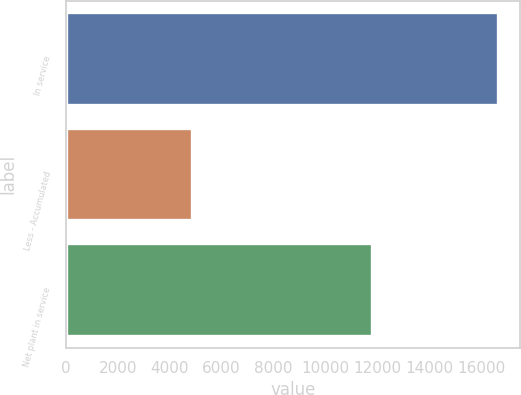Convert chart to OTSL. <chart><loc_0><loc_0><loc_500><loc_500><bar_chart><fcel>In service<fcel>Less - Accumulated<fcel>Net plant in service<nl><fcel>16658<fcel>4870<fcel>11788<nl></chart> 